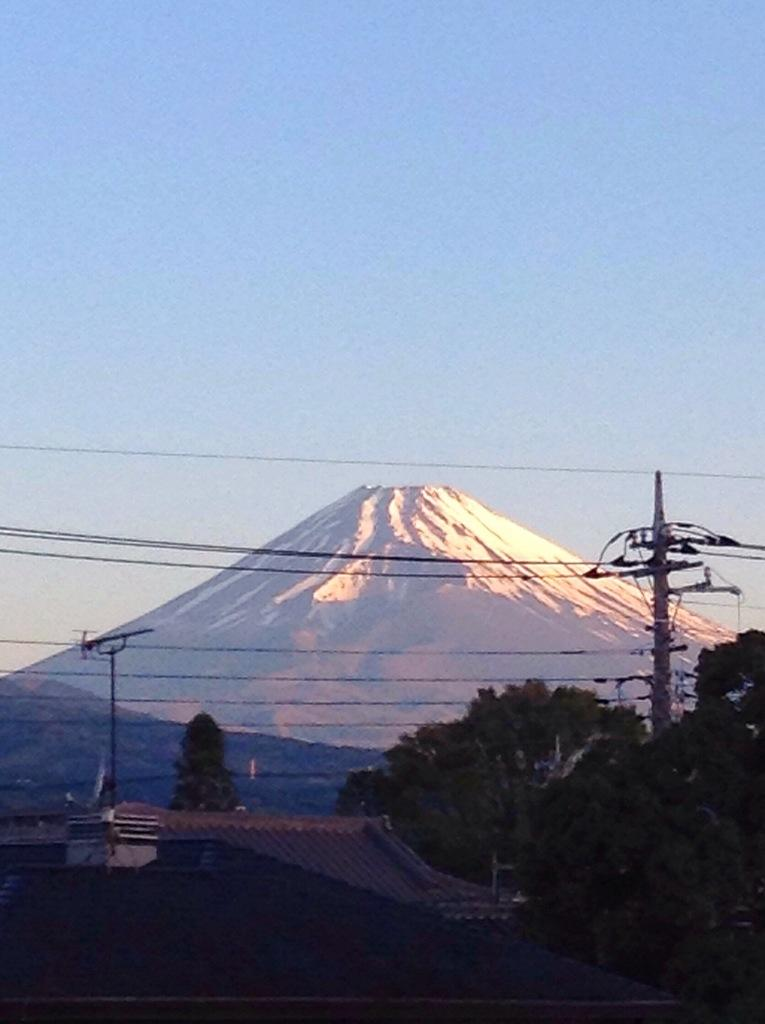What type of structures can be seen in the image? There are buildings in the image. What is located on the right side of the image? There are trees and a pole on the right side of the image. What can be seen in the background of the image? There is a hill and the sky visible in the background of the image. What is the price of the ornament hanging from the pole in the image? There is no ornament hanging from the pole in the image, so it is not possible to determine its price. What type of chalk is being used to draw on the hill in the background? There is no chalk or drawing activity visible in the image, as it features buildings, trees, a pole, and a hill in the background. 